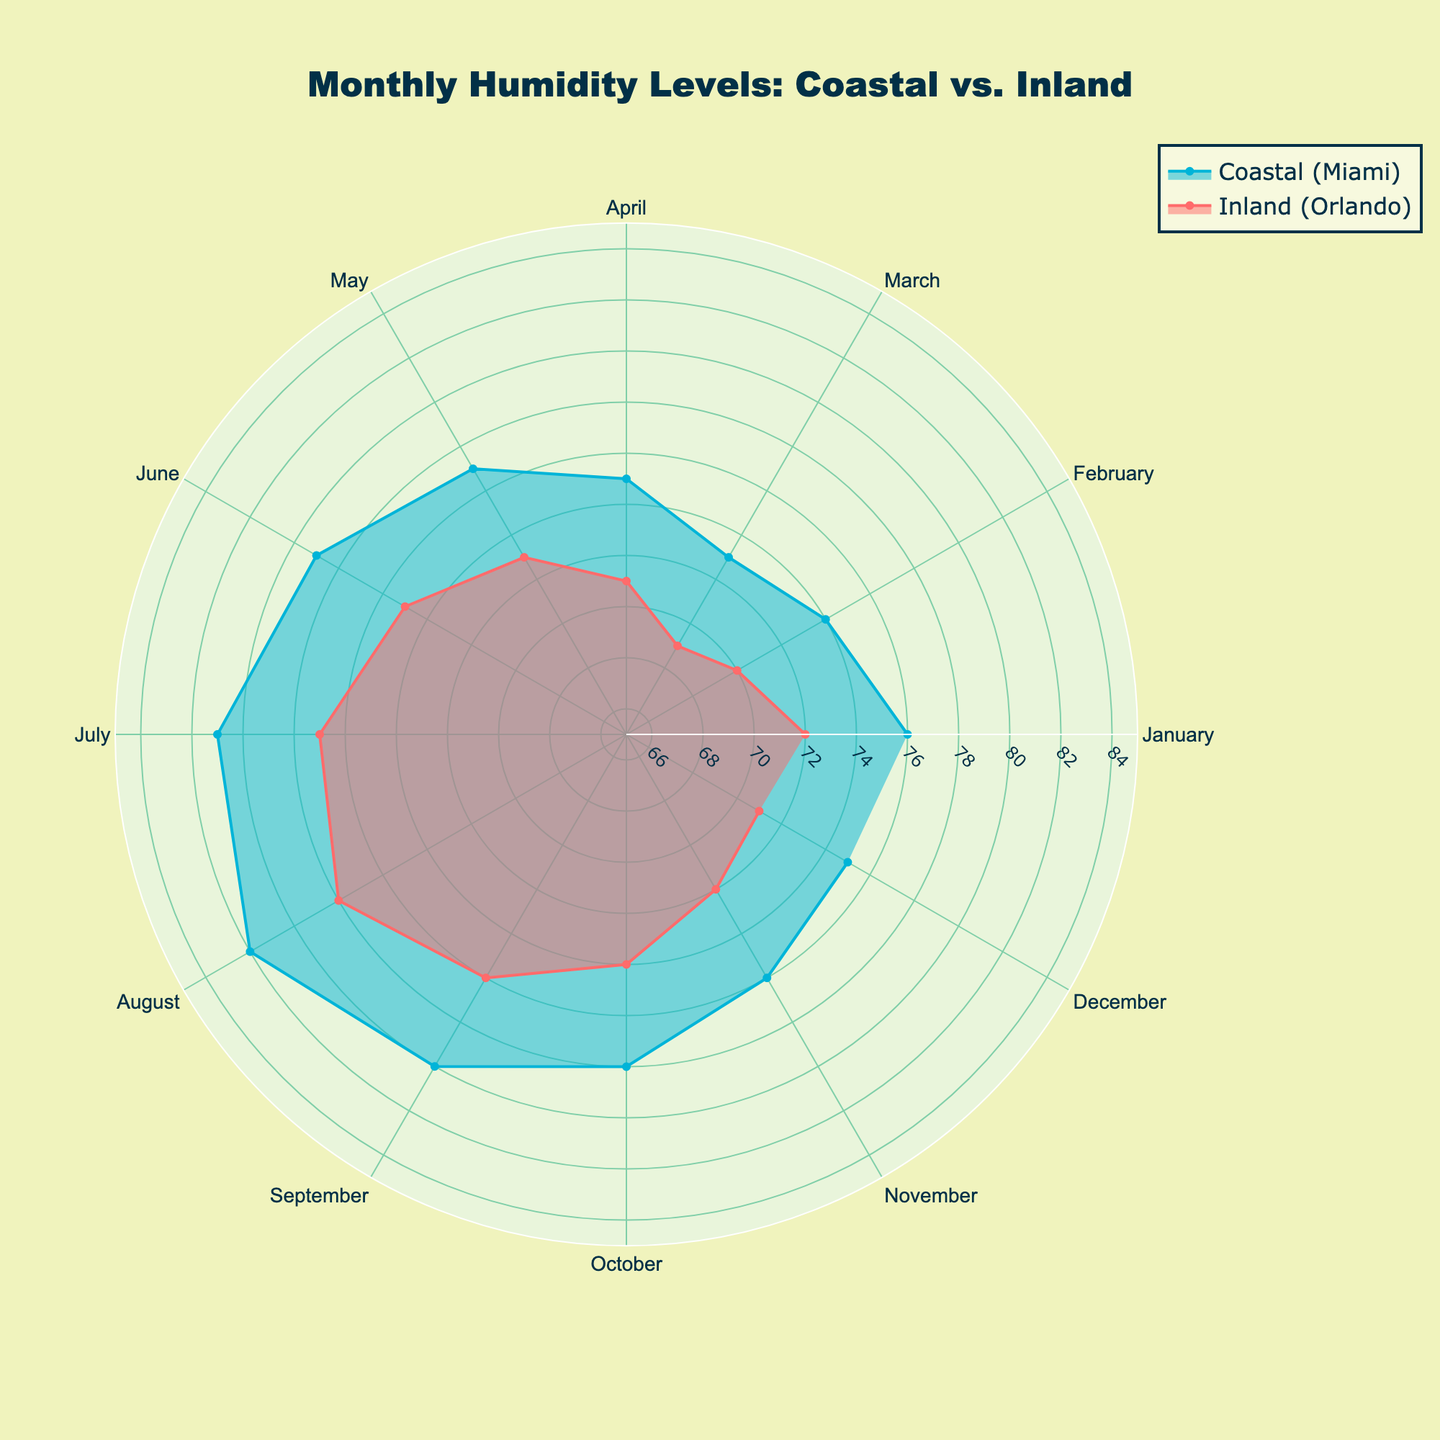what's the title of the figure? The title of the figure can be found at the top; it is intended to describe the overall theme or focus of the plot. In this case, it indicates a comparison of humidity levels throughout the year between coastal and inland locations.
Answer: Monthly Humidity Levels: Coastal vs. Inland what is the humidity range displayed on the radial axis? The radial axis represents the range of humidity levels displayed in the form of circular bands. By inspecting the concentric circles, one can determine the minimum and maximum values represented.
Answer: 65 to 85 which location has higher humidity in July? By examining the points corresponding to July for each location, you can observe which line extends further from the center (higher radial distance). Miami, represented in a specific color, extends further out than Orlando.
Answer: Miami which month has the lowest humidity in the inland area? For Orlando, you need to find the point that is closest to the center of the polar chart, representing the lowest radial value (humidity). By examining the respective position for each month, the closest point indicates the lowest humidity.
Answer: March what are the colors used to represent coastal and inland areas? The fill and line colors of the respective areas on the plot indicate the different locations. The coastal area (Miami) and inland area (Orlando) have distinct colors which provide visual separation.
Answer: Coastal: blue, Inland: red which location shows a more significant variation in humidity across months? By comparing the extent of the spread (distance from the center) of the points for each location across the months, observe which area shows a wider range. The locations with a broader spread across the polar area exhibit more significant variations. Miami shows a wider spread compared to Orlando.
Answer: Miami in which month does both locations have the same humidity level? Analyze the plot to find a point where the radial distance (humidity level) for both coastal and inland locations overlap on the same month, indicating they have equal values. The visual inspection of overlaps can confirm this.
Answer: No month how does the humidity in coastal areas in April compare to June? Look at the positions for coastal areas (Miami) corresponding to April and June and compare their radial distances from the center. This will show whether the humidity level in June is higher, lower, or equal to April. The radial distance for June is further from the center than April.
Answer: Higher in June what is the average humidity level in Miami from January to December? To find the average, sum the humidity values for each month from the coastal location (Miami) and divide by the number of months (12). The calculation is (76+74+73+75+77+79+81+82+80+78+76+75) / 12. Detailed steps: 76+74+73+75+77+79+81+82+80+78+76+75 = 946; 946/12 = 78.833
Answer: 78.833 